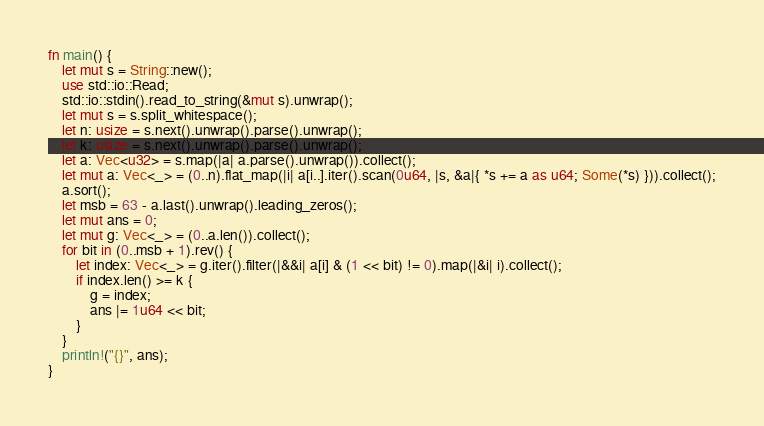<code> <loc_0><loc_0><loc_500><loc_500><_Rust_>fn main() {
	let mut s = String::new();
	use std::io::Read;
	std::io::stdin().read_to_string(&mut s).unwrap();
	let mut s = s.split_whitespace();
	let n: usize = s.next().unwrap().parse().unwrap();
	let k: usize = s.next().unwrap().parse().unwrap();
	let a: Vec<u32> = s.map(|a| a.parse().unwrap()).collect();
	let mut a: Vec<_> = (0..n).flat_map(|i| a[i..].iter().scan(0u64, |s, &a|{ *s += a as u64; Some(*s) })).collect();
	a.sort();
	let msb = 63 - a.last().unwrap().leading_zeros();
	let mut ans = 0;
	let mut g: Vec<_> = (0..a.len()).collect();
	for bit in (0..msb + 1).rev() {
		let index: Vec<_> = g.iter().filter(|&&i| a[i] & (1 << bit) != 0).map(|&i| i).collect();
		if index.len() >= k {
			g = index;
			ans |= 1u64 << bit;
		}
	}
	println!("{}", ans);
}
</code> 